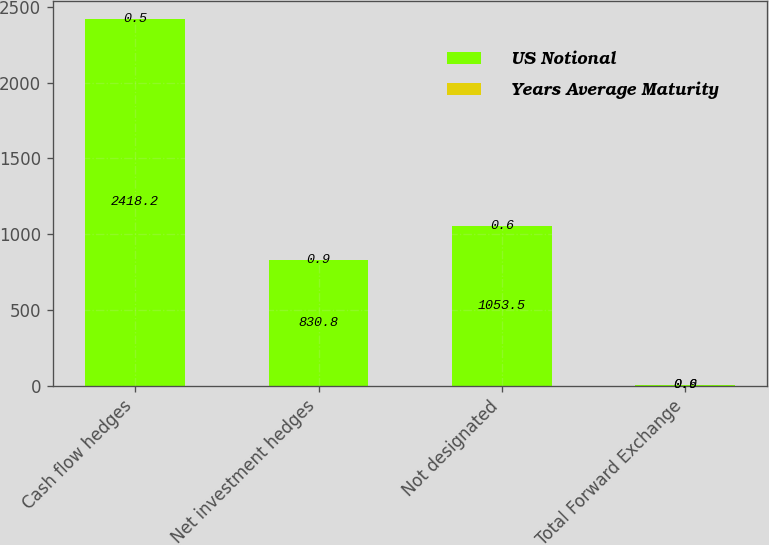Convert chart. <chart><loc_0><loc_0><loc_500><loc_500><stacked_bar_chart><ecel><fcel>Cash flow hedges<fcel>Net investment hedges<fcel>Not designated<fcel>Total Forward Exchange<nl><fcel>US Notional<fcel>2418.2<fcel>830.8<fcel>1053.5<fcel>0.9<nl><fcel>Years Average Maturity<fcel>0.5<fcel>0.9<fcel>0.6<fcel>0.6<nl></chart> 